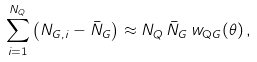Convert formula to latex. <formula><loc_0><loc_0><loc_500><loc_500>\sum _ { i = 1 } ^ { N _ { Q } } \left ( N _ { G , i } - \bar { N } _ { G } \right ) \approx N _ { Q } \, \bar { N } _ { G } \, w _ { \mathrm Q G } ( \theta ) \, ,</formula> 